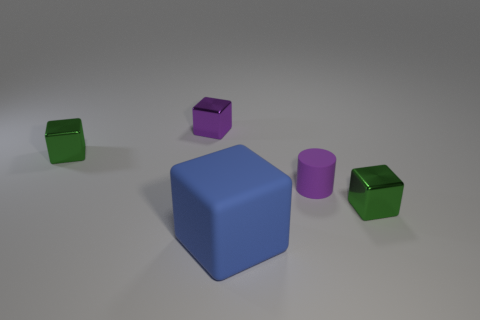Are there any small purple matte cylinders right of the purple shiny block?
Give a very brief answer. Yes. How many objects are either things that are on the right side of the big blue rubber block or purple metallic cubes that are behind the tiny matte cylinder?
Make the answer very short. 3. What number of other small matte things have the same color as the small rubber object?
Your answer should be compact. 0. What color is the large rubber object that is the same shape as the tiny purple shiny thing?
Offer a very short reply. Blue. There is a object that is both in front of the small matte thing and right of the big blue matte cube; what is its shape?
Keep it short and to the point. Cube. Are there more shiny cubes than big matte cubes?
Offer a very short reply. Yes. What material is the big blue block?
Keep it short and to the point. Rubber. Are there any other things that are the same size as the purple cylinder?
Offer a very short reply. Yes. What size is the other purple thing that is the same shape as the big object?
Provide a succinct answer. Small. There is a purple metallic block that is left of the matte block; are there any small purple objects that are to the right of it?
Offer a very short reply. Yes. 